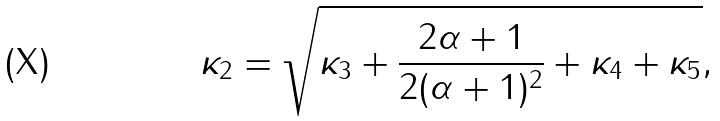Convert formula to latex. <formula><loc_0><loc_0><loc_500><loc_500>\kappa _ { 2 } = \sqrt { \kappa _ { 3 } + \frac { 2 \alpha + 1 } { 2 ( \alpha + 1 ) ^ { 2 } } + \kappa _ { 4 } + \kappa _ { 5 } } ,</formula> 